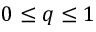<formula> <loc_0><loc_0><loc_500><loc_500>0 \leq q \leq 1</formula> 